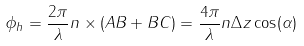<formula> <loc_0><loc_0><loc_500><loc_500>\phi _ { h } = \frac { 2 \pi } { \lambda } n \times ( A B + B C ) = \frac { 4 \pi } { \lambda } n \Delta z \cos ( \alpha )</formula> 